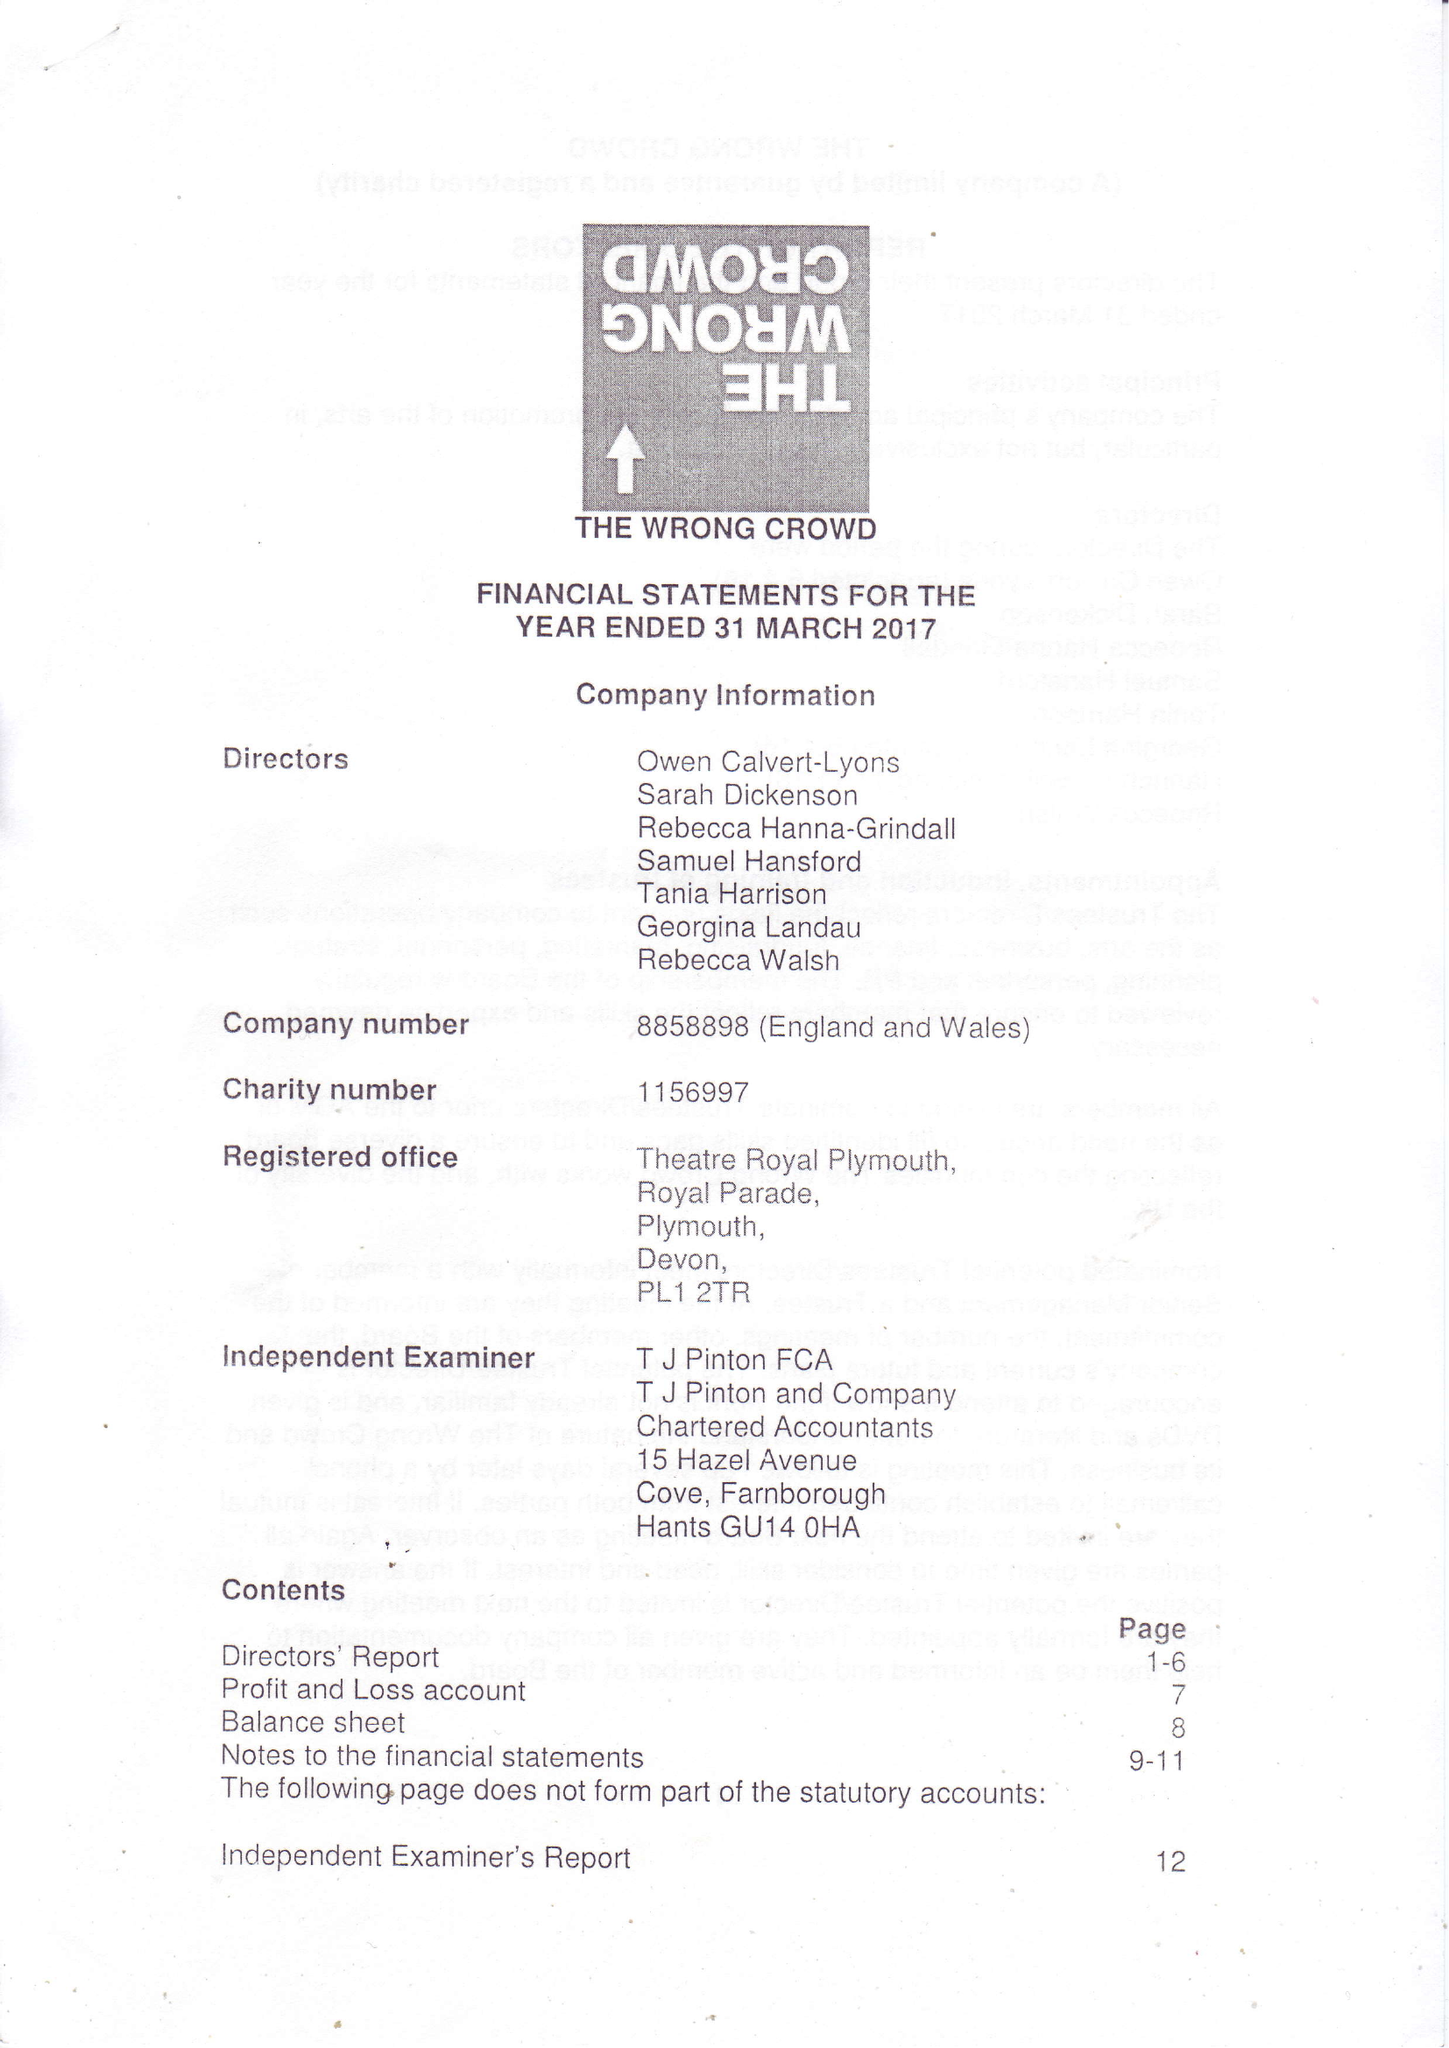What is the value for the charity_name?
Answer the question using a single word or phrase. The Wrong Crowd 